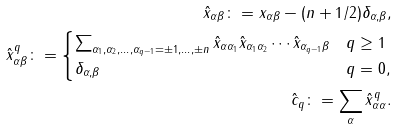Convert formula to latex. <formula><loc_0><loc_0><loc_500><loc_500>\hat { x } _ { \alpha \beta } \colon = x _ { \alpha \beta } - ( n + 1 / 2 ) \delta _ { \alpha , \beta } , \\ \hat { x } _ { \alpha \beta } ^ { q } \colon = \begin{cases} \sum _ { \alpha _ { 1 } , \alpha _ { 2 } , \dots , \alpha _ { q - 1 } = \pm 1 , \dots , \pm n } \hat { x } _ { \alpha \alpha _ { 1 } } \hat { x } _ { \alpha _ { 1 } \alpha _ { 2 } } \cdots \hat { x } _ { \alpha _ { q - 1 } \beta } & q \geq 1 \\ \delta _ { \alpha , \beta } & q = 0 , \end{cases} \\ \hat { c } _ { q } \colon = \sum _ { \alpha } \hat { x } _ { \alpha \alpha } ^ { q } .</formula> 